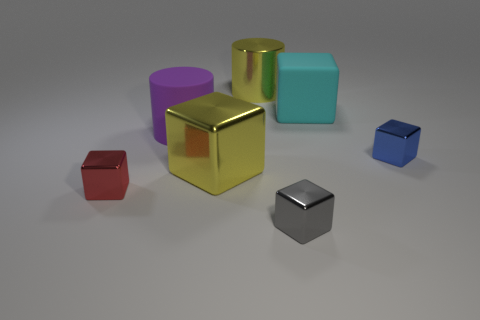Subtract all yellow shiny blocks. How many blocks are left? 4 Subtract all blue cubes. How many cubes are left? 4 Subtract all cyan blocks. Subtract all cyan cylinders. How many blocks are left? 4 Add 3 small blue shiny objects. How many objects exist? 10 Subtract all blocks. How many objects are left? 2 Add 2 rubber objects. How many rubber objects are left? 4 Add 1 small blue cubes. How many small blue cubes exist? 2 Subtract 0 blue spheres. How many objects are left? 7 Subtract all big yellow metal spheres. Subtract all cyan cubes. How many objects are left? 6 